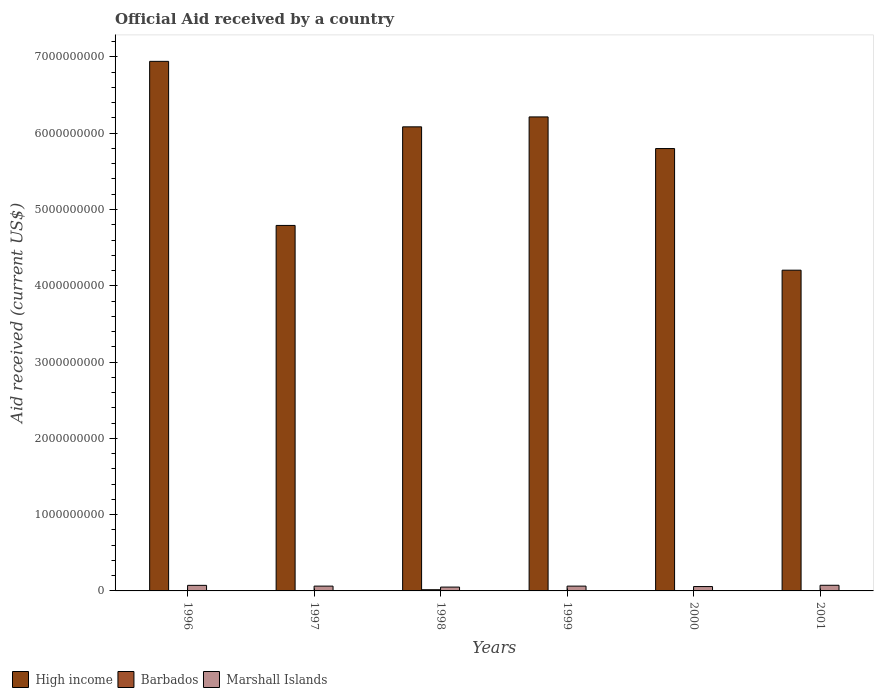Are the number of bars per tick equal to the number of legend labels?
Your response must be concise. No. How many bars are there on the 4th tick from the left?
Your answer should be very brief. 2. How many bars are there on the 1st tick from the right?
Offer a terse response. 2. What is the label of the 1st group of bars from the left?
Offer a very short reply. 1996. In how many cases, is the number of bars for a given year not equal to the number of legend labels?
Offer a very short reply. 2. What is the net official aid received in High income in 1998?
Your answer should be very brief. 6.08e+09. Across all years, what is the maximum net official aid received in Barbados?
Ensure brevity in your answer.  1.57e+07. What is the total net official aid received in Barbados in the graph?
Give a very brief answer. 2.44e+07. What is the difference between the net official aid received in High income in 1997 and that in 2001?
Offer a terse response. 5.87e+08. What is the difference between the net official aid received in High income in 2000 and the net official aid received in Marshall Islands in 1998?
Keep it short and to the point. 5.75e+09. What is the average net official aid received in Barbados per year?
Your response must be concise. 4.08e+06. In the year 2001, what is the difference between the net official aid received in Marshall Islands and net official aid received in High income?
Your response must be concise. -4.13e+09. What is the ratio of the net official aid received in High income in 1999 to that in 2000?
Keep it short and to the point. 1.07. What is the difference between the highest and the second highest net official aid received in Marshall Islands?
Your answer should be very brief. 1.07e+06. What is the difference between the highest and the lowest net official aid received in Marshall Islands?
Provide a short and direct response. 2.37e+07. In how many years, is the net official aid received in High income greater than the average net official aid received in High income taken over all years?
Keep it short and to the point. 4. Is the sum of the net official aid received in Marshall Islands in 1996 and 2000 greater than the maximum net official aid received in High income across all years?
Ensure brevity in your answer.  No. Is it the case that in every year, the sum of the net official aid received in Barbados and net official aid received in High income is greater than the net official aid received in Marshall Islands?
Provide a succinct answer. Yes. How many bars are there?
Offer a very short reply. 16. How many years are there in the graph?
Give a very brief answer. 6. Are the values on the major ticks of Y-axis written in scientific E-notation?
Keep it short and to the point. No. Where does the legend appear in the graph?
Give a very brief answer. Bottom left. How are the legend labels stacked?
Provide a short and direct response. Horizontal. What is the title of the graph?
Offer a terse response. Official Aid received by a country. Does "India" appear as one of the legend labels in the graph?
Provide a short and direct response. No. What is the label or title of the Y-axis?
Give a very brief answer. Aid received (current US$). What is the Aid received (current US$) in High income in 1996?
Make the answer very short. 6.94e+09. What is the Aid received (current US$) of Barbados in 1996?
Your answer should be compact. 4.23e+06. What is the Aid received (current US$) in Marshall Islands in 1996?
Your answer should be compact. 7.29e+07. What is the Aid received (current US$) of High income in 1997?
Give a very brief answer. 4.79e+09. What is the Aid received (current US$) of Barbados in 1997?
Provide a short and direct response. 4.32e+06. What is the Aid received (current US$) of Marshall Islands in 1997?
Give a very brief answer. 6.29e+07. What is the Aid received (current US$) in High income in 1998?
Make the answer very short. 6.08e+09. What is the Aid received (current US$) of Barbados in 1998?
Give a very brief answer. 1.57e+07. What is the Aid received (current US$) of Marshall Islands in 1998?
Your response must be concise. 5.03e+07. What is the Aid received (current US$) of High income in 1999?
Your response must be concise. 6.21e+09. What is the Aid received (current US$) of Barbados in 1999?
Give a very brief answer. 0. What is the Aid received (current US$) in Marshall Islands in 1999?
Keep it short and to the point. 6.29e+07. What is the Aid received (current US$) in High income in 2000?
Offer a very short reply. 5.80e+09. What is the Aid received (current US$) in Marshall Islands in 2000?
Offer a very short reply. 5.72e+07. What is the Aid received (current US$) of High income in 2001?
Offer a very short reply. 4.20e+09. What is the Aid received (current US$) of Barbados in 2001?
Offer a terse response. 0. What is the Aid received (current US$) in Marshall Islands in 2001?
Offer a terse response. 7.40e+07. Across all years, what is the maximum Aid received (current US$) in High income?
Offer a very short reply. 6.94e+09. Across all years, what is the maximum Aid received (current US$) of Barbados?
Your answer should be compact. 1.57e+07. Across all years, what is the maximum Aid received (current US$) in Marshall Islands?
Your response must be concise. 7.40e+07. Across all years, what is the minimum Aid received (current US$) in High income?
Your answer should be compact. 4.20e+09. Across all years, what is the minimum Aid received (current US$) in Barbados?
Offer a very short reply. 0. Across all years, what is the minimum Aid received (current US$) of Marshall Islands?
Offer a terse response. 5.03e+07. What is the total Aid received (current US$) in High income in the graph?
Your response must be concise. 3.40e+1. What is the total Aid received (current US$) in Barbados in the graph?
Your response must be concise. 2.44e+07. What is the total Aid received (current US$) of Marshall Islands in the graph?
Offer a terse response. 3.80e+08. What is the difference between the Aid received (current US$) in High income in 1996 and that in 1997?
Offer a terse response. 2.15e+09. What is the difference between the Aid received (current US$) of Barbados in 1996 and that in 1997?
Your response must be concise. -9.00e+04. What is the difference between the Aid received (current US$) of Marshall Islands in 1996 and that in 1997?
Provide a succinct answer. 1.00e+07. What is the difference between the Aid received (current US$) of High income in 1996 and that in 1998?
Your response must be concise. 8.58e+08. What is the difference between the Aid received (current US$) of Barbados in 1996 and that in 1998?
Offer a very short reply. -1.14e+07. What is the difference between the Aid received (current US$) in Marshall Islands in 1996 and that in 1998?
Provide a succinct answer. 2.26e+07. What is the difference between the Aid received (current US$) in High income in 1996 and that in 1999?
Your answer should be compact. 7.28e+08. What is the difference between the Aid received (current US$) in Marshall Islands in 1996 and that in 1999?
Make the answer very short. 1.00e+07. What is the difference between the Aid received (current US$) of High income in 1996 and that in 2000?
Provide a short and direct response. 1.14e+09. What is the difference between the Aid received (current US$) in Barbados in 1996 and that in 2000?
Give a very brief answer. 3.99e+06. What is the difference between the Aid received (current US$) of Marshall Islands in 1996 and that in 2000?
Ensure brevity in your answer.  1.57e+07. What is the difference between the Aid received (current US$) of High income in 1996 and that in 2001?
Provide a short and direct response. 2.74e+09. What is the difference between the Aid received (current US$) of Marshall Islands in 1996 and that in 2001?
Provide a short and direct response. -1.07e+06. What is the difference between the Aid received (current US$) of High income in 1997 and that in 1998?
Provide a succinct answer. -1.29e+09. What is the difference between the Aid received (current US$) of Barbados in 1997 and that in 1998?
Provide a succinct answer. -1.13e+07. What is the difference between the Aid received (current US$) in Marshall Islands in 1997 and that in 1998?
Give a very brief answer. 1.26e+07. What is the difference between the Aid received (current US$) in High income in 1997 and that in 1999?
Keep it short and to the point. -1.42e+09. What is the difference between the Aid received (current US$) in High income in 1997 and that in 2000?
Give a very brief answer. -1.01e+09. What is the difference between the Aid received (current US$) of Barbados in 1997 and that in 2000?
Ensure brevity in your answer.  4.08e+06. What is the difference between the Aid received (current US$) in Marshall Islands in 1997 and that in 2000?
Provide a succinct answer. 5.70e+06. What is the difference between the Aid received (current US$) of High income in 1997 and that in 2001?
Your answer should be compact. 5.87e+08. What is the difference between the Aid received (current US$) of Marshall Islands in 1997 and that in 2001?
Your response must be concise. -1.11e+07. What is the difference between the Aid received (current US$) in High income in 1998 and that in 1999?
Your response must be concise. -1.30e+08. What is the difference between the Aid received (current US$) in Marshall Islands in 1998 and that in 1999?
Provide a short and direct response. -1.26e+07. What is the difference between the Aid received (current US$) in High income in 1998 and that in 2000?
Keep it short and to the point. 2.85e+08. What is the difference between the Aid received (current US$) of Barbados in 1998 and that in 2000?
Give a very brief answer. 1.54e+07. What is the difference between the Aid received (current US$) of Marshall Islands in 1998 and that in 2000?
Your response must be concise. -6.90e+06. What is the difference between the Aid received (current US$) of High income in 1998 and that in 2001?
Your response must be concise. 1.88e+09. What is the difference between the Aid received (current US$) in Marshall Islands in 1998 and that in 2001?
Ensure brevity in your answer.  -2.37e+07. What is the difference between the Aid received (current US$) in High income in 1999 and that in 2000?
Offer a terse response. 4.15e+08. What is the difference between the Aid received (current US$) in Marshall Islands in 1999 and that in 2000?
Your response must be concise. 5.67e+06. What is the difference between the Aid received (current US$) of High income in 1999 and that in 2001?
Make the answer very short. 2.01e+09. What is the difference between the Aid received (current US$) in Marshall Islands in 1999 and that in 2001?
Provide a short and direct response. -1.11e+07. What is the difference between the Aid received (current US$) of High income in 2000 and that in 2001?
Make the answer very short. 1.59e+09. What is the difference between the Aid received (current US$) in Marshall Islands in 2000 and that in 2001?
Provide a succinct answer. -1.68e+07. What is the difference between the Aid received (current US$) in High income in 1996 and the Aid received (current US$) in Barbados in 1997?
Provide a short and direct response. 6.94e+09. What is the difference between the Aid received (current US$) in High income in 1996 and the Aid received (current US$) in Marshall Islands in 1997?
Give a very brief answer. 6.88e+09. What is the difference between the Aid received (current US$) in Barbados in 1996 and the Aid received (current US$) in Marshall Islands in 1997?
Make the answer very short. -5.87e+07. What is the difference between the Aid received (current US$) of High income in 1996 and the Aid received (current US$) of Barbados in 1998?
Keep it short and to the point. 6.93e+09. What is the difference between the Aid received (current US$) in High income in 1996 and the Aid received (current US$) in Marshall Islands in 1998?
Offer a very short reply. 6.89e+09. What is the difference between the Aid received (current US$) of Barbados in 1996 and the Aid received (current US$) of Marshall Islands in 1998?
Your answer should be compact. -4.61e+07. What is the difference between the Aid received (current US$) in High income in 1996 and the Aid received (current US$) in Marshall Islands in 1999?
Offer a terse response. 6.88e+09. What is the difference between the Aid received (current US$) of Barbados in 1996 and the Aid received (current US$) of Marshall Islands in 1999?
Provide a succinct answer. -5.87e+07. What is the difference between the Aid received (current US$) in High income in 1996 and the Aid received (current US$) in Barbados in 2000?
Your answer should be very brief. 6.94e+09. What is the difference between the Aid received (current US$) in High income in 1996 and the Aid received (current US$) in Marshall Islands in 2000?
Your answer should be very brief. 6.88e+09. What is the difference between the Aid received (current US$) in Barbados in 1996 and the Aid received (current US$) in Marshall Islands in 2000?
Offer a very short reply. -5.30e+07. What is the difference between the Aid received (current US$) in High income in 1996 and the Aid received (current US$) in Marshall Islands in 2001?
Keep it short and to the point. 6.87e+09. What is the difference between the Aid received (current US$) in Barbados in 1996 and the Aid received (current US$) in Marshall Islands in 2001?
Your answer should be compact. -6.98e+07. What is the difference between the Aid received (current US$) in High income in 1997 and the Aid received (current US$) in Barbados in 1998?
Offer a very short reply. 4.78e+09. What is the difference between the Aid received (current US$) in High income in 1997 and the Aid received (current US$) in Marshall Islands in 1998?
Give a very brief answer. 4.74e+09. What is the difference between the Aid received (current US$) in Barbados in 1997 and the Aid received (current US$) in Marshall Islands in 1998?
Your answer should be very brief. -4.60e+07. What is the difference between the Aid received (current US$) in High income in 1997 and the Aid received (current US$) in Marshall Islands in 1999?
Keep it short and to the point. 4.73e+09. What is the difference between the Aid received (current US$) in Barbados in 1997 and the Aid received (current US$) in Marshall Islands in 1999?
Ensure brevity in your answer.  -5.86e+07. What is the difference between the Aid received (current US$) in High income in 1997 and the Aid received (current US$) in Barbados in 2000?
Make the answer very short. 4.79e+09. What is the difference between the Aid received (current US$) of High income in 1997 and the Aid received (current US$) of Marshall Islands in 2000?
Your answer should be very brief. 4.73e+09. What is the difference between the Aid received (current US$) of Barbados in 1997 and the Aid received (current US$) of Marshall Islands in 2000?
Offer a very short reply. -5.29e+07. What is the difference between the Aid received (current US$) of High income in 1997 and the Aid received (current US$) of Marshall Islands in 2001?
Make the answer very short. 4.72e+09. What is the difference between the Aid received (current US$) in Barbados in 1997 and the Aid received (current US$) in Marshall Islands in 2001?
Your response must be concise. -6.97e+07. What is the difference between the Aid received (current US$) in High income in 1998 and the Aid received (current US$) in Marshall Islands in 1999?
Your answer should be very brief. 6.02e+09. What is the difference between the Aid received (current US$) in Barbados in 1998 and the Aid received (current US$) in Marshall Islands in 1999?
Offer a very short reply. -4.72e+07. What is the difference between the Aid received (current US$) in High income in 1998 and the Aid received (current US$) in Barbados in 2000?
Give a very brief answer. 6.08e+09. What is the difference between the Aid received (current US$) of High income in 1998 and the Aid received (current US$) of Marshall Islands in 2000?
Your answer should be compact. 6.03e+09. What is the difference between the Aid received (current US$) of Barbados in 1998 and the Aid received (current US$) of Marshall Islands in 2000?
Your response must be concise. -4.16e+07. What is the difference between the Aid received (current US$) of High income in 1998 and the Aid received (current US$) of Marshall Islands in 2001?
Provide a succinct answer. 6.01e+09. What is the difference between the Aid received (current US$) of Barbados in 1998 and the Aid received (current US$) of Marshall Islands in 2001?
Your response must be concise. -5.84e+07. What is the difference between the Aid received (current US$) in High income in 1999 and the Aid received (current US$) in Barbados in 2000?
Offer a very short reply. 6.21e+09. What is the difference between the Aid received (current US$) in High income in 1999 and the Aid received (current US$) in Marshall Islands in 2000?
Your response must be concise. 6.16e+09. What is the difference between the Aid received (current US$) of High income in 1999 and the Aid received (current US$) of Marshall Islands in 2001?
Offer a terse response. 6.14e+09. What is the difference between the Aid received (current US$) of High income in 2000 and the Aid received (current US$) of Marshall Islands in 2001?
Your answer should be very brief. 5.72e+09. What is the difference between the Aid received (current US$) in Barbados in 2000 and the Aid received (current US$) in Marshall Islands in 2001?
Your response must be concise. -7.38e+07. What is the average Aid received (current US$) in High income per year?
Offer a terse response. 5.67e+09. What is the average Aid received (current US$) in Barbados per year?
Ensure brevity in your answer.  4.08e+06. What is the average Aid received (current US$) of Marshall Islands per year?
Your answer should be compact. 6.34e+07. In the year 1996, what is the difference between the Aid received (current US$) in High income and Aid received (current US$) in Barbados?
Your response must be concise. 6.94e+09. In the year 1996, what is the difference between the Aid received (current US$) in High income and Aid received (current US$) in Marshall Islands?
Ensure brevity in your answer.  6.87e+09. In the year 1996, what is the difference between the Aid received (current US$) of Barbados and Aid received (current US$) of Marshall Islands?
Offer a very short reply. -6.87e+07. In the year 1997, what is the difference between the Aid received (current US$) of High income and Aid received (current US$) of Barbados?
Offer a terse response. 4.79e+09. In the year 1997, what is the difference between the Aid received (current US$) in High income and Aid received (current US$) in Marshall Islands?
Give a very brief answer. 4.73e+09. In the year 1997, what is the difference between the Aid received (current US$) of Barbados and Aid received (current US$) of Marshall Islands?
Ensure brevity in your answer.  -5.86e+07. In the year 1998, what is the difference between the Aid received (current US$) in High income and Aid received (current US$) in Barbados?
Give a very brief answer. 6.07e+09. In the year 1998, what is the difference between the Aid received (current US$) of High income and Aid received (current US$) of Marshall Islands?
Your answer should be very brief. 6.03e+09. In the year 1998, what is the difference between the Aid received (current US$) in Barbados and Aid received (current US$) in Marshall Islands?
Your response must be concise. -3.47e+07. In the year 1999, what is the difference between the Aid received (current US$) in High income and Aid received (current US$) in Marshall Islands?
Your answer should be very brief. 6.15e+09. In the year 2000, what is the difference between the Aid received (current US$) in High income and Aid received (current US$) in Barbados?
Your answer should be compact. 5.80e+09. In the year 2000, what is the difference between the Aid received (current US$) of High income and Aid received (current US$) of Marshall Islands?
Keep it short and to the point. 5.74e+09. In the year 2000, what is the difference between the Aid received (current US$) of Barbados and Aid received (current US$) of Marshall Islands?
Give a very brief answer. -5.70e+07. In the year 2001, what is the difference between the Aid received (current US$) in High income and Aid received (current US$) in Marshall Islands?
Offer a terse response. 4.13e+09. What is the ratio of the Aid received (current US$) in High income in 1996 to that in 1997?
Ensure brevity in your answer.  1.45. What is the ratio of the Aid received (current US$) of Barbados in 1996 to that in 1997?
Your response must be concise. 0.98. What is the ratio of the Aid received (current US$) of Marshall Islands in 1996 to that in 1997?
Keep it short and to the point. 1.16. What is the ratio of the Aid received (current US$) of High income in 1996 to that in 1998?
Keep it short and to the point. 1.14. What is the ratio of the Aid received (current US$) of Barbados in 1996 to that in 1998?
Offer a terse response. 0.27. What is the ratio of the Aid received (current US$) of Marshall Islands in 1996 to that in 1998?
Keep it short and to the point. 1.45. What is the ratio of the Aid received (current US$) in High income in 1996 to that in 1999?
Offer a very short reply. 1.12. What is the ratio of the Aid received (current US$) of Marshall Islands in 1996 to that in 1999?
Offer a very short reply. 1.16. What is the ratio of the Aid received (current US$) in High income in 1996 to that in 2000?
Provide a succinct answer. 1.2. What is the ratio of the Aid received (current US$) in Barbados in 1996 to that in 2000?
Make the answer very short. 17.62. What is the ratio of the Aid received (current US$) in Marshall Islands in 1996 to that in 2000?
Ensure brevity in your answer.  1.27. What is the ratio of the Aid received (current US$) in High income in 1996 to that in 2001?
Your response must be concise. 1.65. What is the ratio of the Aid received (current US$) in Marshall Islands in 1996 to that in 2001?
Ensure brevity in your answer.  0.99. What is the ratio of the Aid received (current US$) of High income in 1997 to that in 1998?
Keep it short and to the point. 0.79. What is the ratio of the Aid received (current US$) of Barbados in 1997 to that in 1998?
Your answer should be compact. 0.28. What is the ratio of the Aid received (current US$) in Marshall Islands in 1997 to that in 1998?
Your answer should be very brief. 1.25. What is the ratio of the Aid received (current US$) of High income in 1997 to that in 1999?
Offer a terse response. 0.77. What is the ratio of the Aid received (current US$) in Marshall Islands in 1997 to that in 1999?
Provide a succinct answer. 1. What is the ratio of the Aid received (current US$) of High income in 1997 to that in 2000?
Make the answer very short. 0.83. What is the ratio of the Aid received (current US$) in Marshall Islands in 1997 to that in 2000?
Provide a short and direct response. 1.1. What is the ratio of the Aid received (current US$) in High income in 1997 to that in 2001?
Provide a short and direct response. 1.14. What is the ratio of the Aid received (current US$) of Marshall Islands in 1997 to that in 2001?
Your answer should be very brief. 0.85. What is the ratio of the Aid received (current US$) of High income in 1998 to that in 1999?
Ensure brevity in your answer.  0.98. What is the ratio of the Aid received (current US$) of Marshall Islands in 1998 to that in 1999?
Keep it short and to the point. 0.8. What is the ratio of the Aid received (current US$) of High income in 1998 to that in 2000?
Make the answer very short. 1.05. What is the ratio of the Aid received (current US$) in Barbados in 1998 to that in 2000?
Provide a short and direct response. 65.25. What is the ratio of the Aid received (current US$) in Marshall Islands in 1998 to that in 2000?
Give a very brief answer. 0.88. What is the ratio of the Aid received (current US$) in High income in 1998 to that in 2001?
Offer a very short reply. 1.45. What is the ratio of the Aid received (current US$) of Marshall Islands in 1998 to that in 2001?
Offer a very short reply. 0.68. What is the ratio of the Aid received (current US$) in High income in 1999 to that in 2000?
Your response must be concise. 1.07. What is the ratio of the Aid received (current US$) in Marshall Islands in 1999 to that in 2000?
Your response must be concise. 1.1. What is the ratio of the Aid received (current US$) of High income in 1999 to that in 2001?
Keep it short and to the point. 1.48. What is the ratio of the Aid received (current US$) of Marshall Islands in 1999 to that in 2001?
Offer a terse response. 0.85. What is the ratio of the Aid received (current US$) of High income in 2000 to that in 2001?
Your answer should be compact. 1.38. What is the ratio of the Aid received (current US$) in Marshall Islands in 2000 to that in 2001?
Give a very brief answer. 0.77. What is the difference between the highest and the second highest Aid received (current US$) of High income?
Provide a succinct answer. 7.28e+08. What is the difference between the highest and the second highest Aid received (current US$) of Barbados?
Provide a short and direct response. 1.13e+07. What is the difference between the highest and the second highest Aid received (current US$) of Marshall Islands?
Your answer should be very brief. 1.07e+06. What is the difference between the highest and the lowest Aid received (current US$) of High income?
Provide a succinct answer. 2.74e+09. What is the difference between the highest and the lowest Aid received (current US$) of Barbados?
Ensure brevity in your answer.  1.57e+07. What is the difference between the highest and the lowest Aid received (current US$) of Marshall Islands?
Your response must be concise. 2.37e+07. 